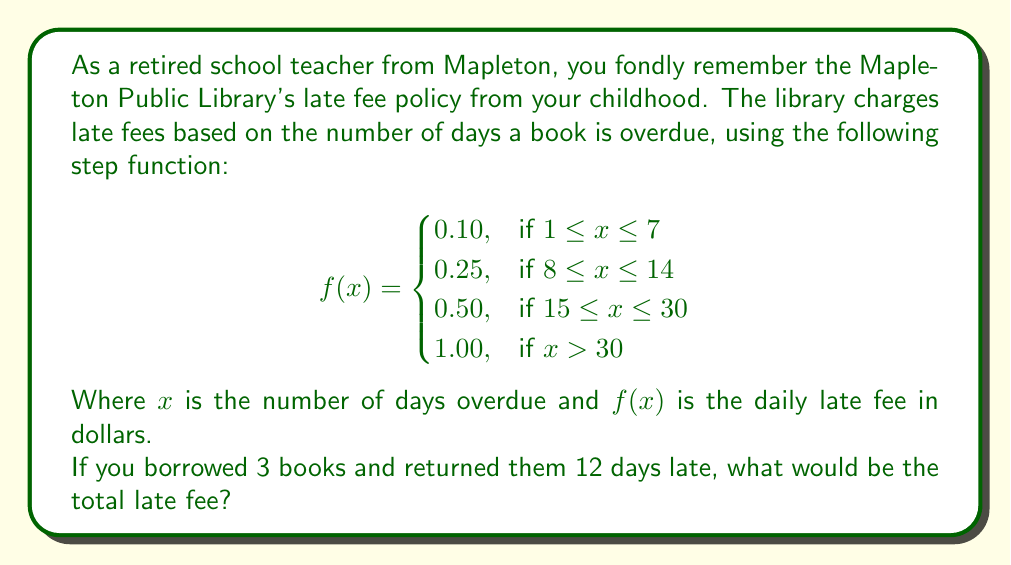Give your solution to this math problem. To solve this problem, we need to follow these steps:

1. Identify the correct fee bracket:
   Since the books are 12 days late, we use the second case of the step function:
   $$0.25 \text{ per day, if } 8 \leq x \leq 14$$

2. Calculate the fee for one book:
   $$\text{Fee per book} = 0.25 \times 12 \text{ days} = $3.00$$

3. Calculate the total fee for all 3 books:
   $$\text{Total fee} = $3.00 \times 3 \text{ books} = $9.00$$

Therefore, the total late fee for returning 3 books 12 days late would be $9.00.
Answer: $9.00 